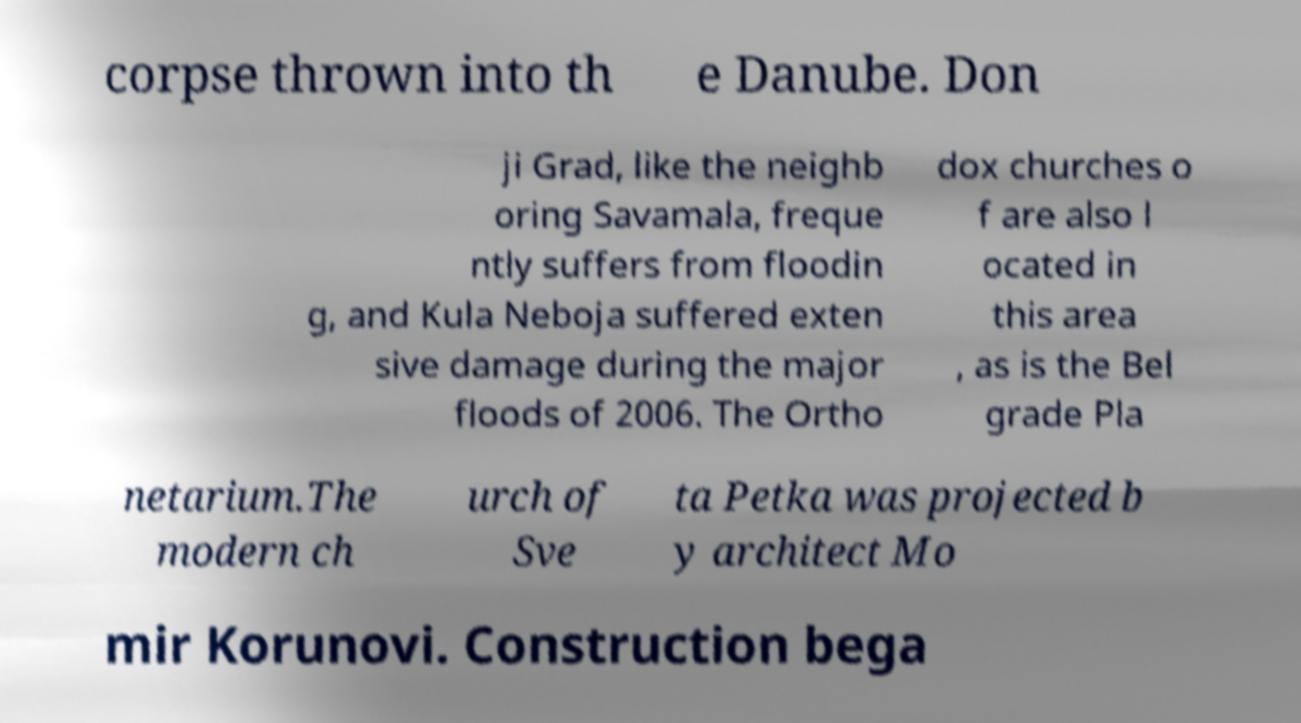Can you read and provide the text displayed in the image?This photo seems to have some interesting text. Can you extract and type it out for me? corpse thrown into th e Danube. Don ji Grad, like the neighb oring Savamala, freque ntly suffers from floodin g, and Kula Neboja suffered exten sive damage during the major floods of 2006. The Ortho dox churches o f are also l ocated in this area , as is the Bel grade Pla netarium.The modern ch urch of Sve ta Petka was projected b y architect Mo mir Korunovi. Construction bega 